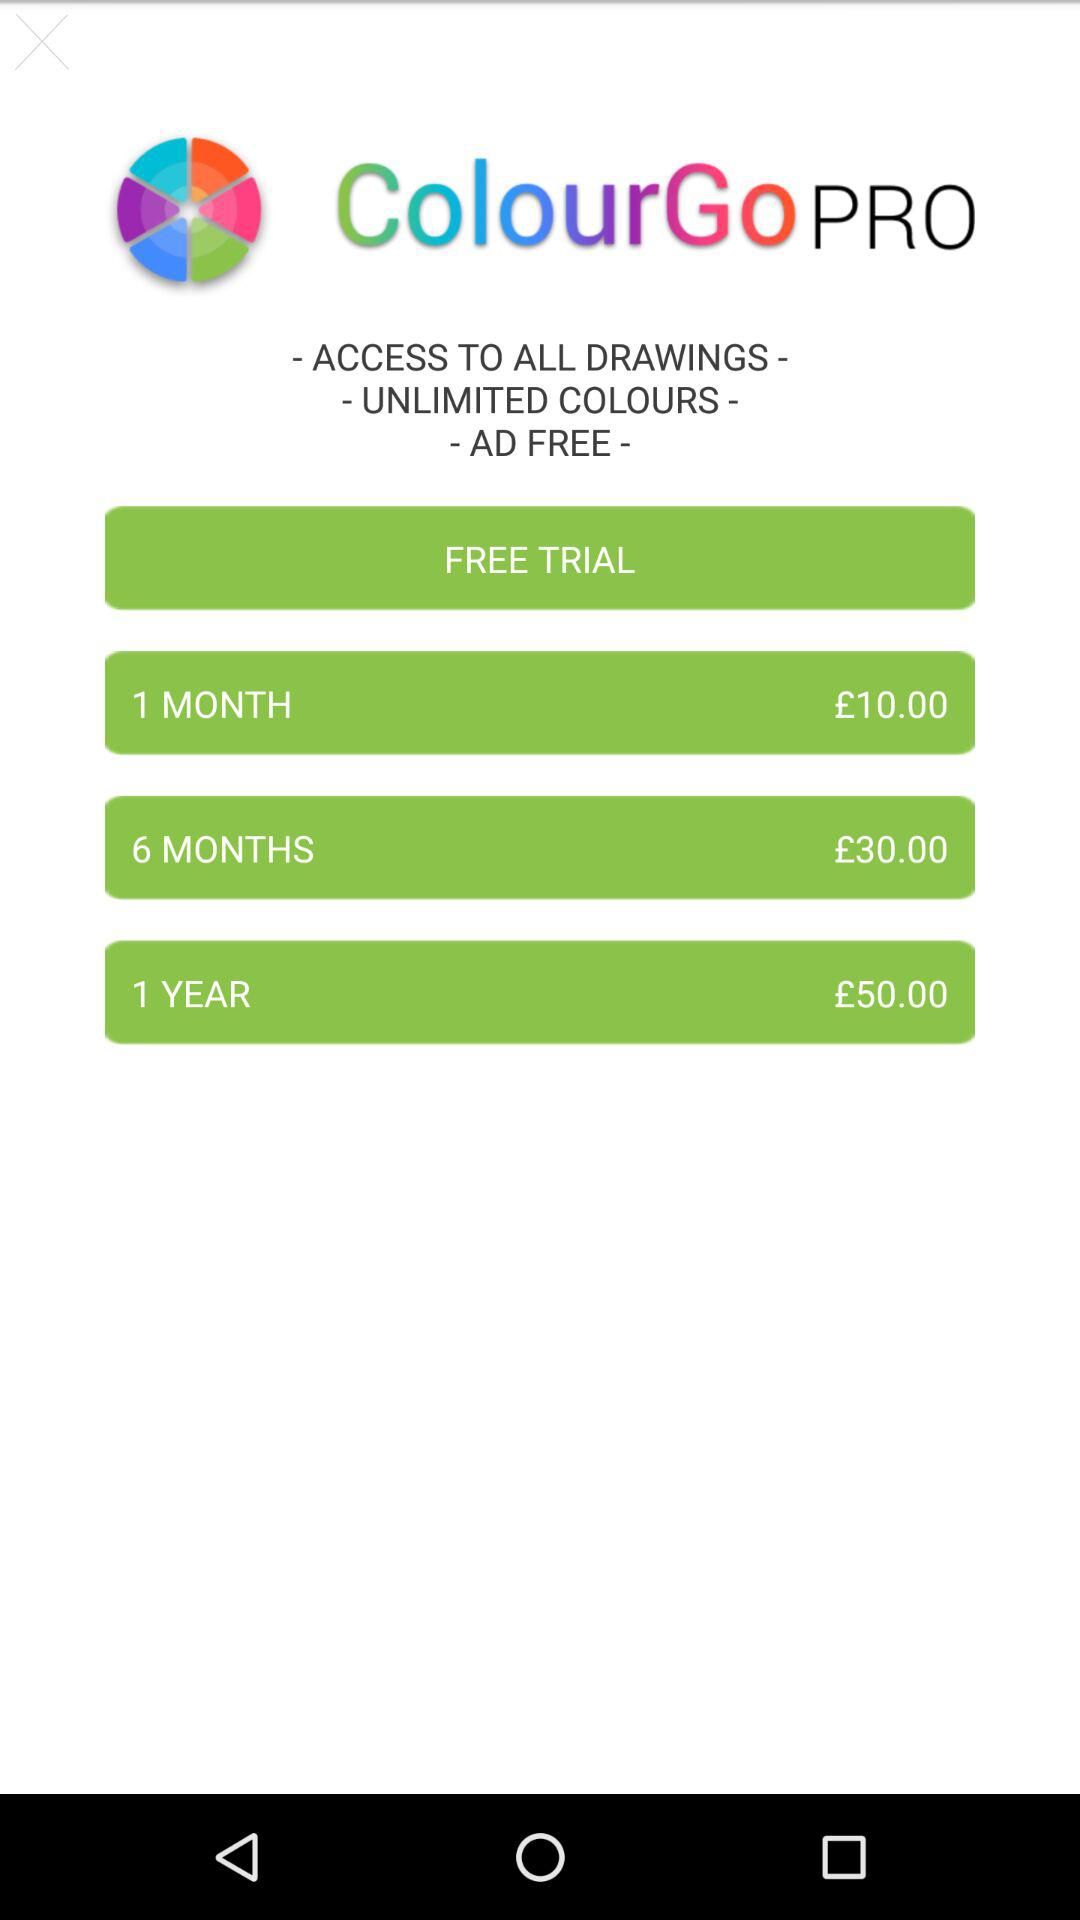What is the subscription price for 6 months? The subscription price for 6 months is £30. 